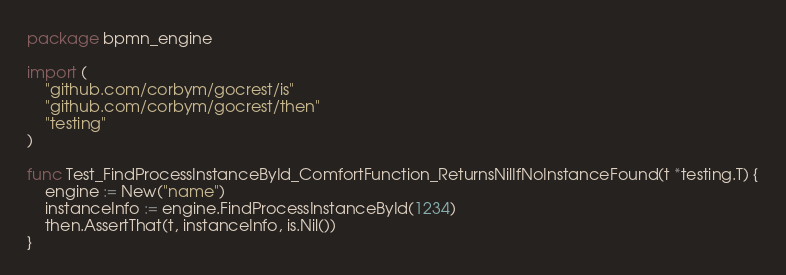<code> <loc_0><loc_0><loc_500><loc_500><_Go_>package bpmn_engine

import (
	"github.com/corbym/gocrest/is"
	"github.com/corbym/gocrest/then"
	"testing"
)

func Test_FindProcessInstanceById_ComfortFunction_ReturnsNilIfNoInstanceFound(t *testing.T) {
	engine := New("name")
	instanceInfo := engine.FindProcessInstanceById(1234)
	then.AssertThat(t, instanceInfo, is.Nil())
}
</code> 